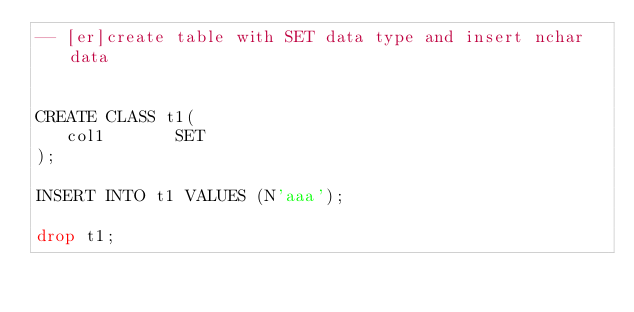<code> <loc_0><loc_0><loc_500><loc_500><_SQL_>-- [er]create table with SET data type and insert nchar data


CREATE CLASS t1(
   col1       SET 
);

INSERT INTO t1 VALUES (N'aaa');

drop t1;</code> 